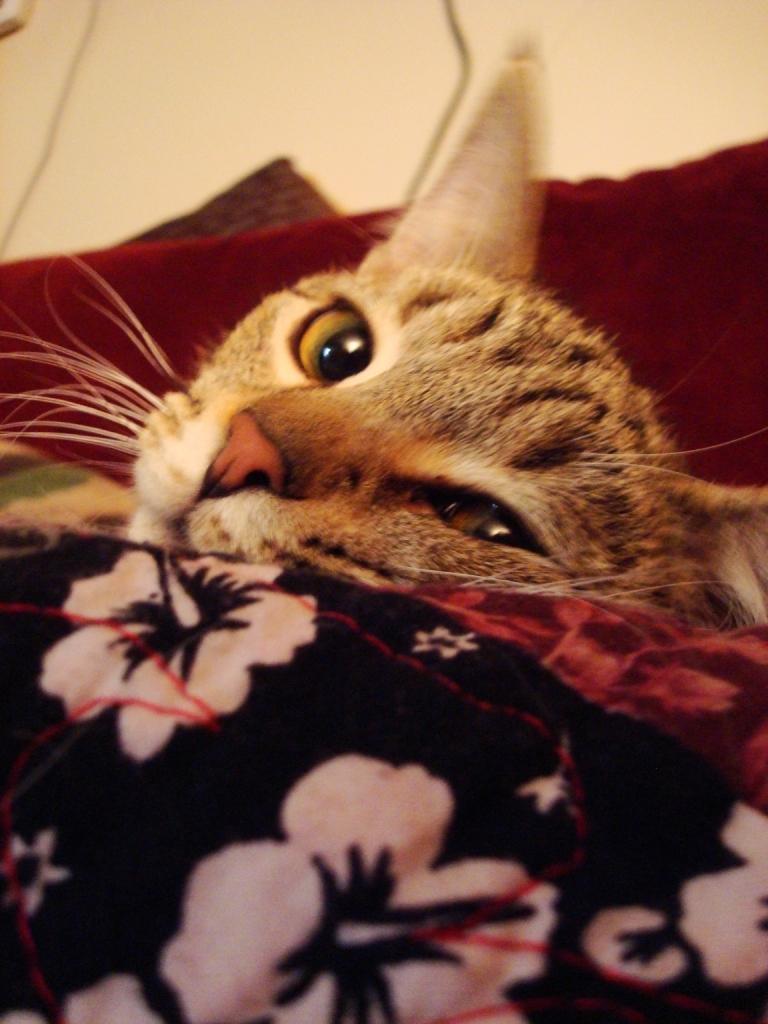How would you summarize this image in a sentence or two? In this picture we can see a cat, clothes and in the background we can see the surface. 